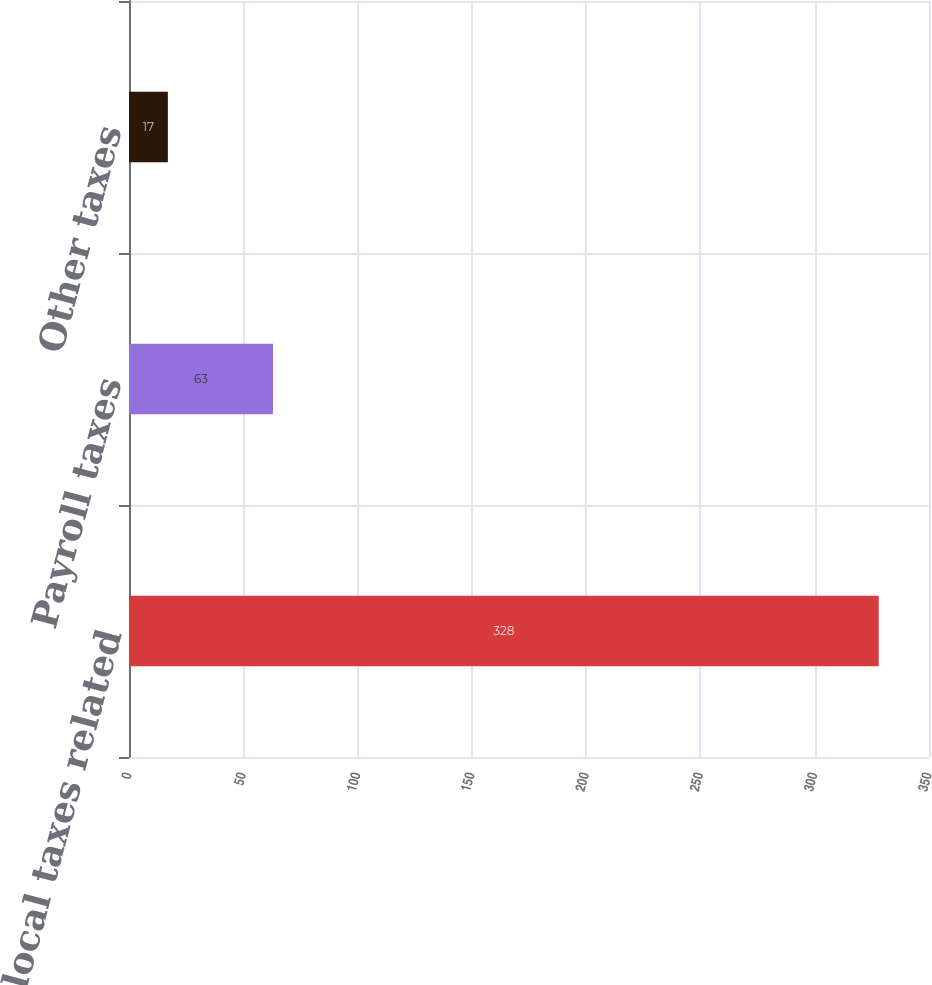<chart> <loc_0><loc_0><loc_500><loc_500><bar_chart><fcel>State and local taxes related<fcel>Payroll taxes<fcel>Other taxes<nl><fcel>328<fcel>63<fcel>17<nl></chart> 